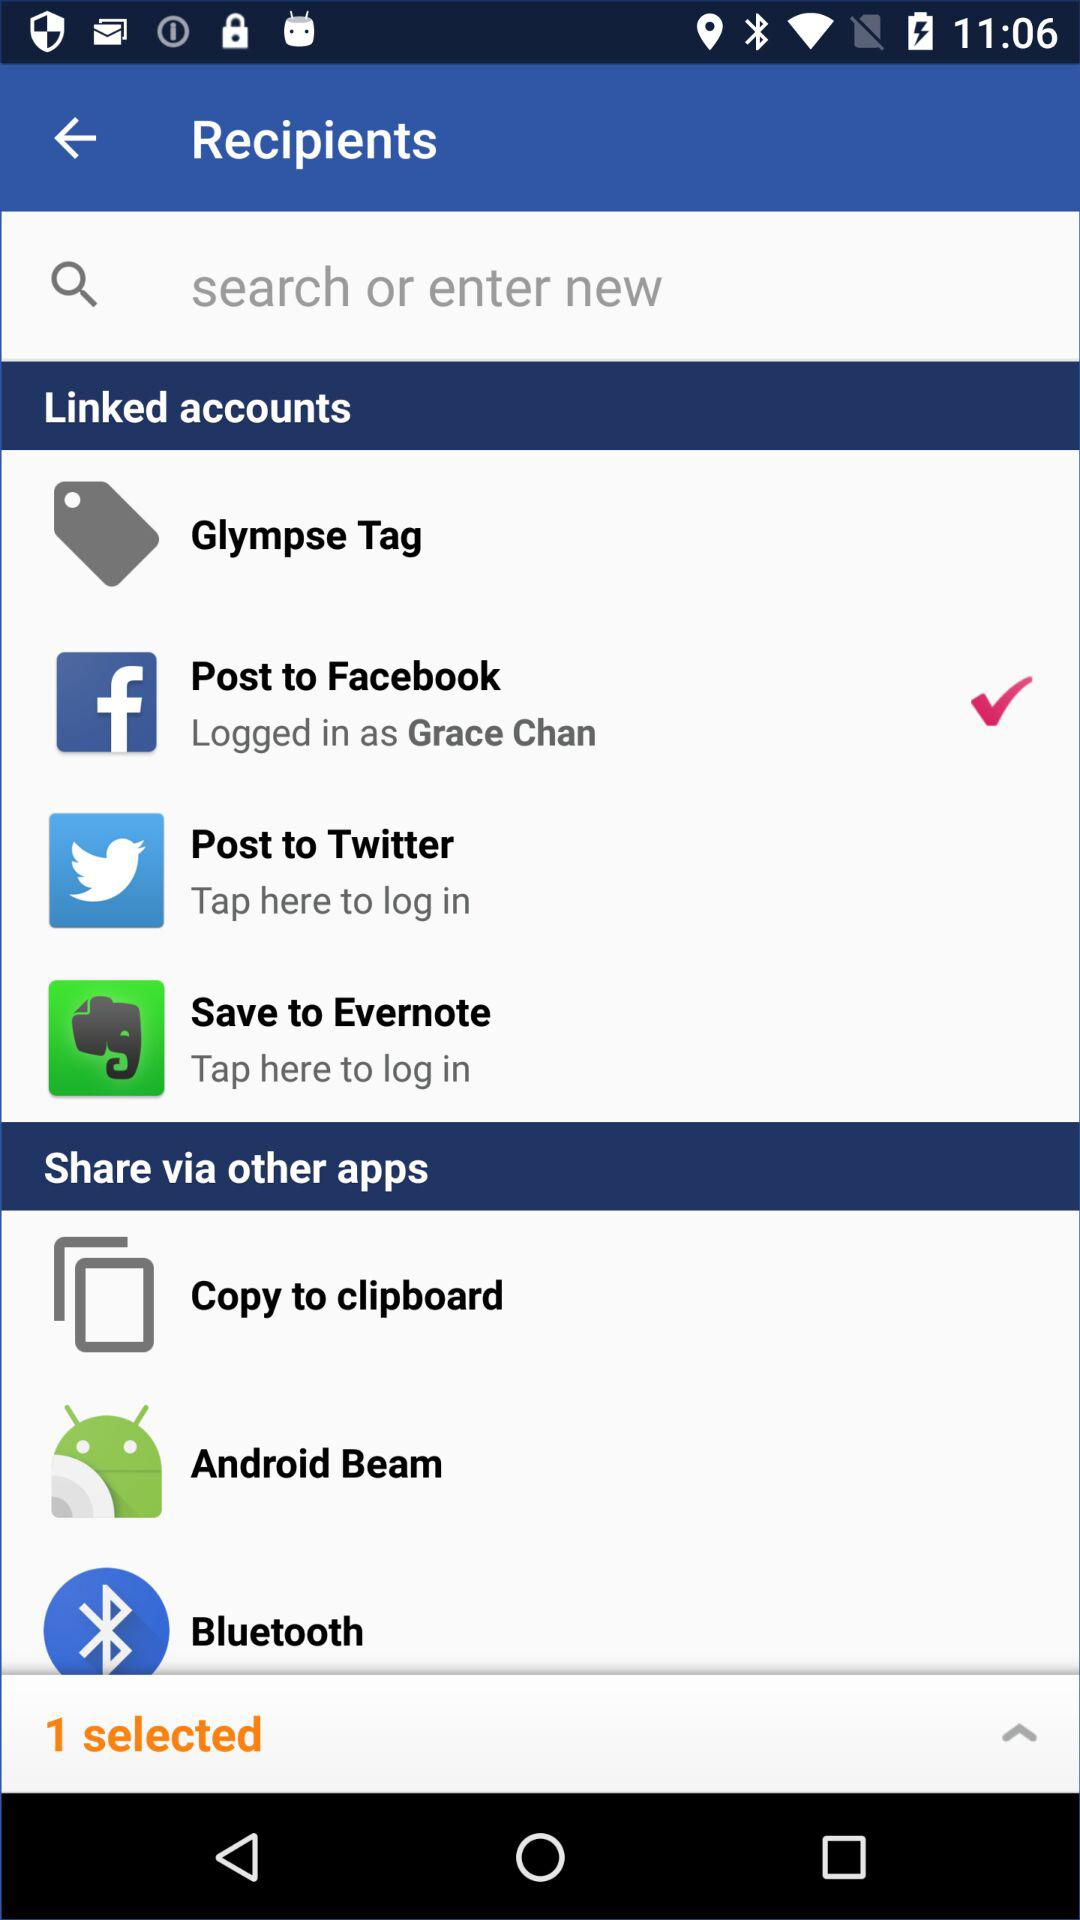How many of the linked accounts are logged in?
Answer the question using a single word or phrase. 1 